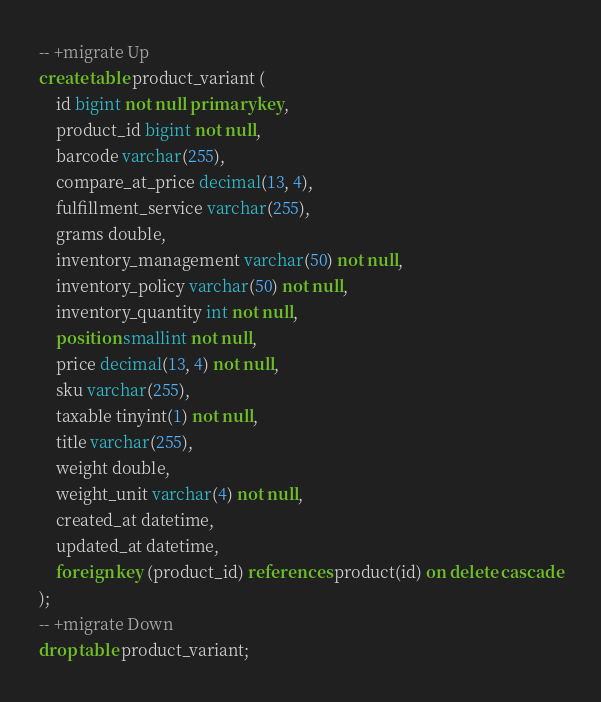<code> <loc_0><loc_0><loc_500><loc_500><_SQL_>-- +migrate Up
create table product_variant (
    id bigint not null primary key,
    product_id bigint not null,
    barcode varchar(255),
    compare_at_price decimal(13, 4),
    fulfillment_service varchar(255),
    grams double,
    inventory_management varchar(50) not null,
    inventory_policy varchar(50) not null,
    inventory_quantity int not null,
    position smallint not null,
    price decimal(13, 4) not null,
    sku varchar(255),
    taxable tinyint(1) not null,
    title varchar(255),
    weight double,
    weight_unit varchar(4) not null,
    created_at datetime,
    updated_at datetime,
    foreign key (product_id) references product(id) on delete cascade
);
-- +migrate Down
drop table product_variant;</code> 